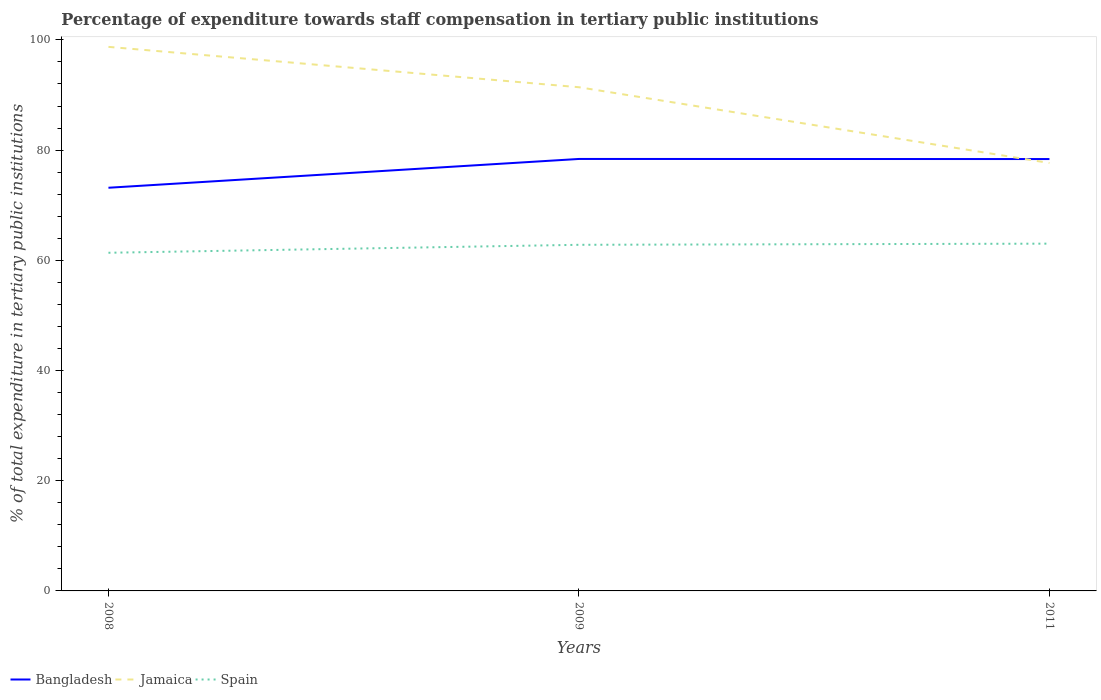Does the line corresponding to Spain intersect with the line corresponding to Jamaica?
Provide a short and direct response. No. Across all years, what is the maximum percentage of expenditure towards staff compensation in Bangladesh?
Make the answer very short. 73.17. In which year was the percentage of expenditure towards staff compensation in Bangladesh maximum?
Offer a terse response. 2008. What is the total percentage of expenditure towards staff compensation in Bangladesh in the graph?
Give a very brief answer. -5.21. What is the difference between the highest and the second highest percentage of expenditure towards staff compensation in Jamaica?
Your answer should be very brief. 21.07. Is the percentage of expenditure towards staff compensation in Jamaica strictly greater than the percentage of expenditure towards staff compensation in Spain over the years?
Your response must be concise. No. What is the difference between two consecutive major ticks on the Y-axis?
Give a very brief answer. 20. Are the values on the major ticks of Y-axis written in scientific E-notation?
Keep it short and to the point. No. Does the graph contain grids?
Make the answer very short. No. What is the title of the graph?
Give a very brief answer. Percentage of expenditure towards staff compensation in tertiary public institutions. Does "Middle income" appear as one of the legend labels in the graph?
Your answer should be very brief. No. What is the label or title of the Y-axis?
Keep it short and to the point. % of total expenditure in tertiary public institutions. What is the % of total expenditure in tertiary public institutions in Bangladesh in 2008?
Provide a succinct answer. 73.17. What is the % of total expenditure in tertiary public institutions of Jamaica in 2008?
Offer a very short reply. 98.74. What is the % of total expenditure in tertiary public institutions in Spain in 2008?
Provide a succinct answer. 61.37. What is the % of total expenditure in tertiary public institutions of Bangladesh in 2009?
Keep it short and to the point. 78.4. What is the % of total expenditure in tertiary public institutions of Jamaica in 2009?
Offer a very short reply. 91.41. What is the % of total expenditure in tertiary public institutions of Spain in 2009?
Provide a short and direct response. 62.82. What is the % of total expenditure in tertiary public institutions of Bangladesh in 2011?
Give a very brief answer. 78.38. What is the % of total expenditure in tertiary public institutions in Jamaica in 2011?
Your answer should be compact. 77.66. What is the % of total expenditure in tertiary public institutions of Spain in 2011?
Provide a succinct answer. 63.03. Across all years, what is the maximum % of total expenditure in tertiary public institutions in Bangladesh?
Your response must be concise. 78.4. Across all years, what is the maximum % of total expenditure in tertiary public institutions of Jamaica?
Ensure brevity in your answer.  98.74. Across all years, what is the maximum % of total expenditure in tertiary public institutions in Spain?
Offer a terse response. 63.03. Across all years, what is the minimum % of total expenditure in tertiary public institutions of Bangladesh?
Ensure brevity in your answer.  73.17. Across all years, what is the minimum % of total expenditure in tertiary public institutions of Jamaica?
Offer a very short reply. 77.66. Across all years, what is the minimum % of total expenditure in tertiary public institutions in Spain?
Give a very brief answer. 61.37. What is the total % of total expenditure in tertiary public institutions in Bangladesh in the graph?
Ensure brevity in your answer.  229.95. What is the total % of total expenditure in tertiary public institutions of Jamaica in the graph?
Provide a succinct answer. 267.81. What is the total % of total expenditure in tertiary public institutions in Spain in the graph?
Provide a short and direct response. 187.21. What is the difference between the % of total expenditure in tertiary public institutions of Bangladesh in 2008 and that in 2009?
Keep it short and to the point. -5.23. What is the difference between the % of total expenditure in tertiary public institutions of Jamaica in 2008 and that in 2009?
Your answer should be very brief. 7.32. What is the difference between the % of total expenditure in tertiary public institutions of Spain in 2008 and that in 2009?
Your response must be concise. -1.44. What is the difference between the % of total expenditure in tertiary public institutions in Bangladesh in 2008 and that in 2011?
Keep it short and to the point. -5.21. What is the difference between the % of total expenditure in tertiary public institutions in Jamaica in 2008 and that in 2011?
Give a very brief answer. 21.07. What is the difference between the % of total expenditure in tertiary public institutions in Spain in 2008 and that in 2011?
Keep it short and to the point. -1.65. What is the difference between the % of total expenditure in tertiary public institutions of Bangladesh in 2009 and that in 2011?
Your response must be concise. 0.02. What is the difference between the % of total expenditure in tertiary public institutions in Jamaica in 2009 and that in 2011?
Your answer should be very brief. 13.75. What is the difference between the % of total expenditure in tertiary public institutions in Spain in 2009 and that in 2011?
Offer a terse response. -0.21. What is the difference between the % of total expenditure in tertiary public institutions in Bangladesh in 2008 and the % of total expenditure in tertiary public institutions in Jamaica in 2009?
Your answer should be very brief. -18.24. What is the difference between the % of total expenditure in tertiary public institutions in Bangladesh in 2008 and the % of total expenditure in tertiary public institutions in Spain in 2009?
Give a very brief answer. 10.35. What is the difference between the % of total expenditure in tertiary public institutions in Jamaica in 2008 and the % of total expenditure in tertiary public institutions in Spain in 2009?
Your response must be concise. 35.92. What is the difference between the % of total expenditure in tertiary public institutions in Bangladesh in 2008 and the % of total expenditure in tertiary public institutions in Jamaica in 2011?
Your answer should be compact. -4.49. What is the difference between the % of total expenditure in tertiary public institutions of Bangladesh in 2008 and the % of total expenditure in tertiary public institutions of Spain in 2011?
Offer a very short reply. 10.14. What is the difference between the % of total expenditure in tertiary public institutions in Jamaica in 2008 and the % of total expenditure in tertiary public institutions in Spain in 2011?
Your answer should be compact. 35.71. What is the difference between the % of total expenditure in tertiary public institutions of Bangladesh in 2009 and the % of total expenditure in tertiary public institutions of Jamaica in 2011?
Make the answer very short. 0.73. What is the difference between the % of total expenditure in tertiary public institutions of Bangladesh in 2009 and the % of total expenditure in tertiary public institutions of Spain in 2011?
Offer a terse response. 15.37. What is the difference between the % of total expenditure in tertiary public institutions in Jamaica in 2009 and the % of total expenditure in tertiary public institutions in Spain in 2011?
Offer a very short reply. 28.39. What is the average % of total expenditure in tertiary public institutions in Bangladesh per year?
Make the answer very short. 76.65. What is the average % of total expenditure in tertiary public institutions of Jamaica per year?
Offer a very short reply. 89.27. What is the average % of total expenditure in tertiary public institutions of Spain per year?
Provide a short and direct response. 62.4. In the year 2008, what is the difference between the % of total expenditure in tertiary public institutions in Bangladesh and % of total expenditure in tertiary public institutions in Jamaica?
Offer a terse response. -25.57. In the year 2008, what is the difference between the % of total expenditure in tertiary public institutions in Bangladesh and % of total expenditure in tertiary public institutions in Spain?
Your response must be concise. 11.8. In the year 2008, what is the difference between the % of total expenditure in tertiary public institutions in Jamaica and % of total expenditure in tertiary public institutions in Spain?
Your answer should be compact. 37.37. In the year 2009, what is the difference between the % of total expenditure in tertiary public institutions in Bangladesh and % of total expenditure in tertiary public institutions in Jamaica?
Your answer should be compact. -13.02. In the year 2009, what is the difference between the % of total expenditure in tertiary public institutions of Bangladesh and % of total expenditure in tertiary public institutions of Spain?
Your answer should be compact. 15.58. In the year 2009, what is the difference between the % of total expenditure in tertiary public institutions in Jamaica and % of total expenditure in tertiary public institutions in Spain?
Ensure brevity in your answer.  28.6. In the year 2011, what is the difference between the % of total expenditure in tertiary public institutions in Bangladesh and % of total expenditure in tertiary public institutions in Jamaica?
Ensure brevity in your answer.  0.72. In the year 2011, what is the difference between the % of total expenditure in tertiary public institutions of Bangladesh and % of total expenditure in tertiary public institutions of Spain?
Keep it short and to the point. 15.35. In the year 2011, what is the difference between the % of total expenditure in tertiary public institutions of Jamaica and % of total expenditure in tertiary public institutions of Spain?
Your answer should be very brief. 14.64. What is the ratio of the % of total expenditure in tertiary public institutions in Jamaica in 2008 to that in 2009?
Provide a short and direct response. 1.08. What is the ratio of the % of total expenditure in tertiary public institutions in Spain in 2008 to that in 2009?
Offer a terse response. 0.98. What is the ratio of the % of total expenditure in tertiary public institutions of Bangladesh in 2008 to that in 2011?
Give a very brief answer. 0.93. What is the ratio of the % of total expenditure in tertiary public institutions in Jamaica in 2008 to that in 2011?
Make the answer very short. 1.27. What is the ratio of the % of total expenditure in tertiary public institutions of Spain in 2008 to that in 2011?
Keep it short and to the point. 0.97. What is the ratio of the % of total expenditure in tertiary public institutions of Jamaica in 2009 to that in 2011?
Your answer should be compact. 1.18. What is the difference between the highest and the second highest % of total expenditure in tertiary public institutions of Bangladesh?
Offer a very short reply. 0.02. What is the difference between the highest and the second highest % of total expenditure in tertiary public institutions of Jamaica?
Your answer should be compact. 7.32. What is the difference between the highest and the second highest % of total expenditure in tertiary public institutions in Spain?
Your answer should be very brief. 0.21. What is the difference between the highest and the lowest % of total expenditure in tertiary public institutions of Bangladesh?
Offer a very short reply. 5.23. What is the difference between the highest and the lowest % of total expenditure in tertiary public institutions of Jamaica?
Make the answer very short. 21.07. What is the difference between the highest and the lowest % of total expenditure in tertiary public institutions in Spain?
Your answer should be very brief. 1.65. 